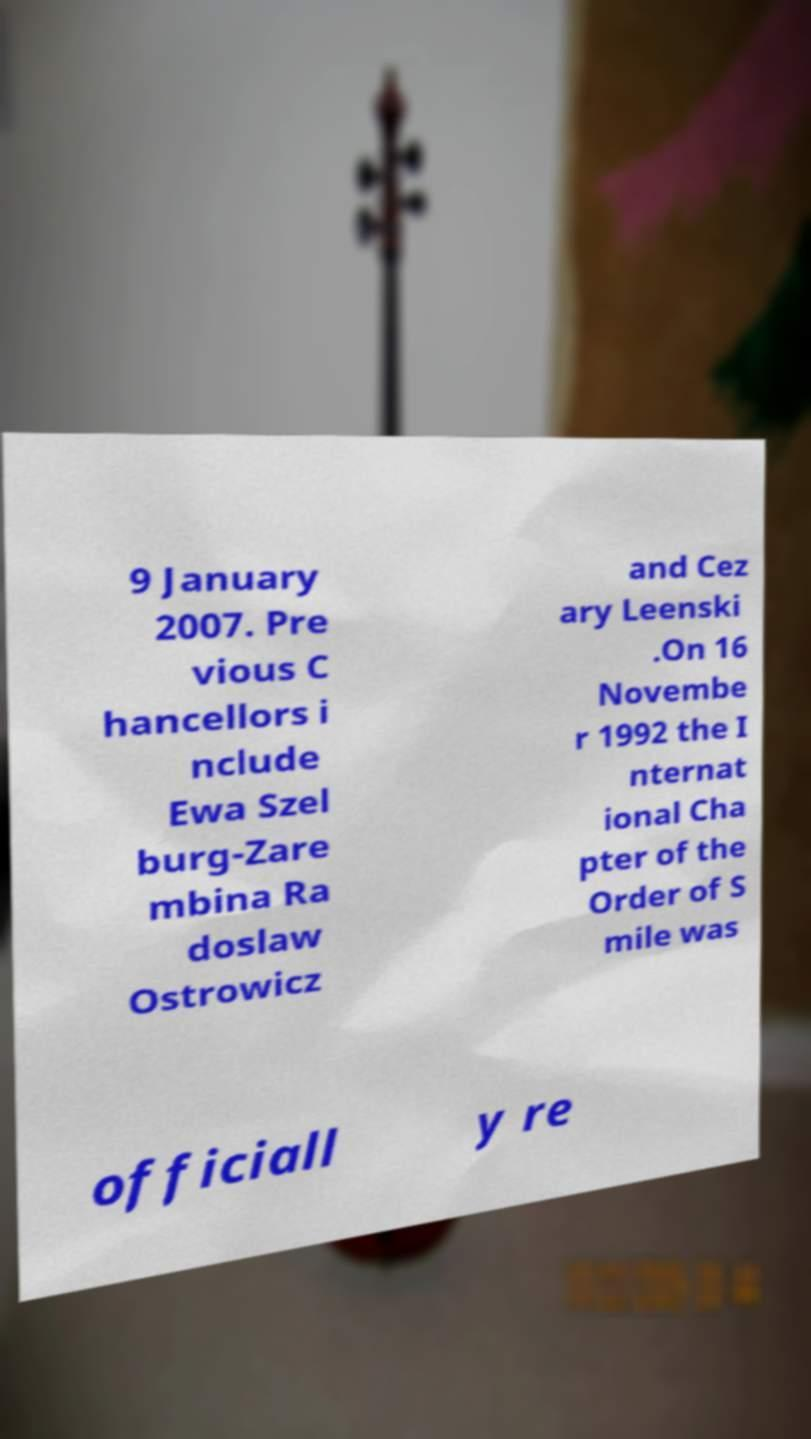What messages or text are displayed in this image? I need them in a readable, typed format. 9 January 2007. Pre vious C hancellors i nclude Ewa Szel burg-Zare mbina Ra doslaw Ostrowicz and Cez ary Leenski .On 16 Novembe r 1992 the I nternat ional Cha pter of the Order of S mile was officiall y re 